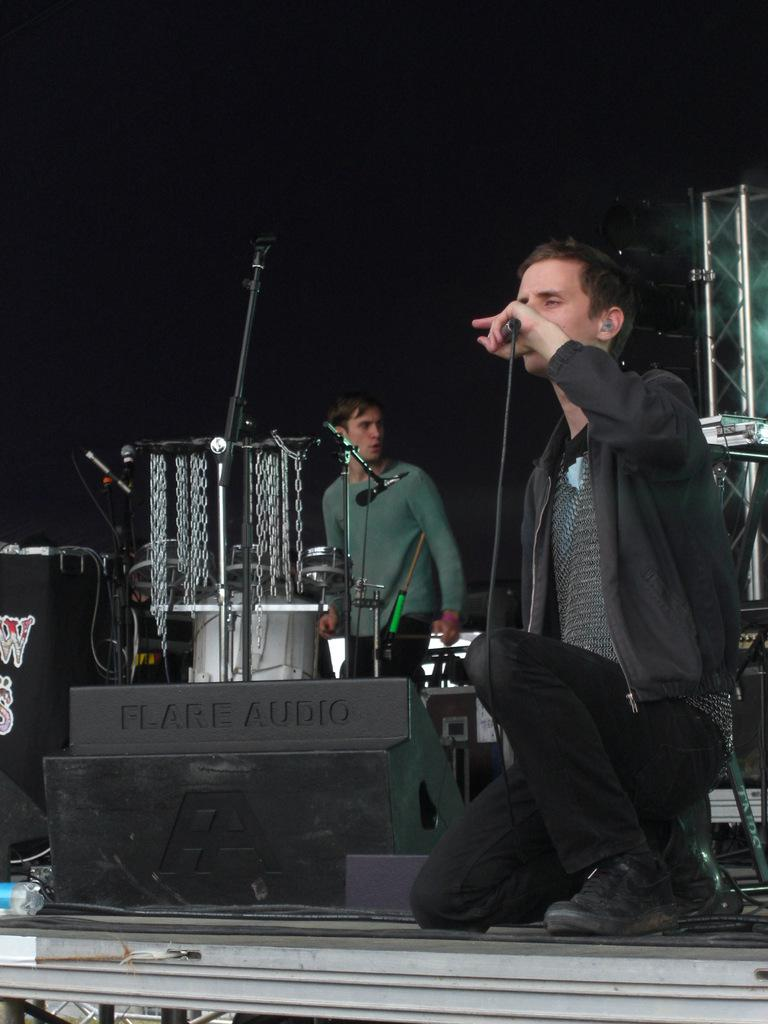How many people are in the image? There are two men in the image. What are the positions of the two men in the image? One man is standing, and the other is sitting on his knees. What is the sitting man holding in his hand? The sitting man is holding a mic in his hand. What can be seen in the background of the image? There are stands and chains in the background of the image. How would you describe the lighting in the image? The background is dark. Can you see any boats in the image? No, there are no boats present in the image. What type of ocean creatures can be seen in the image? There are no ocean creatures visible in the image. 